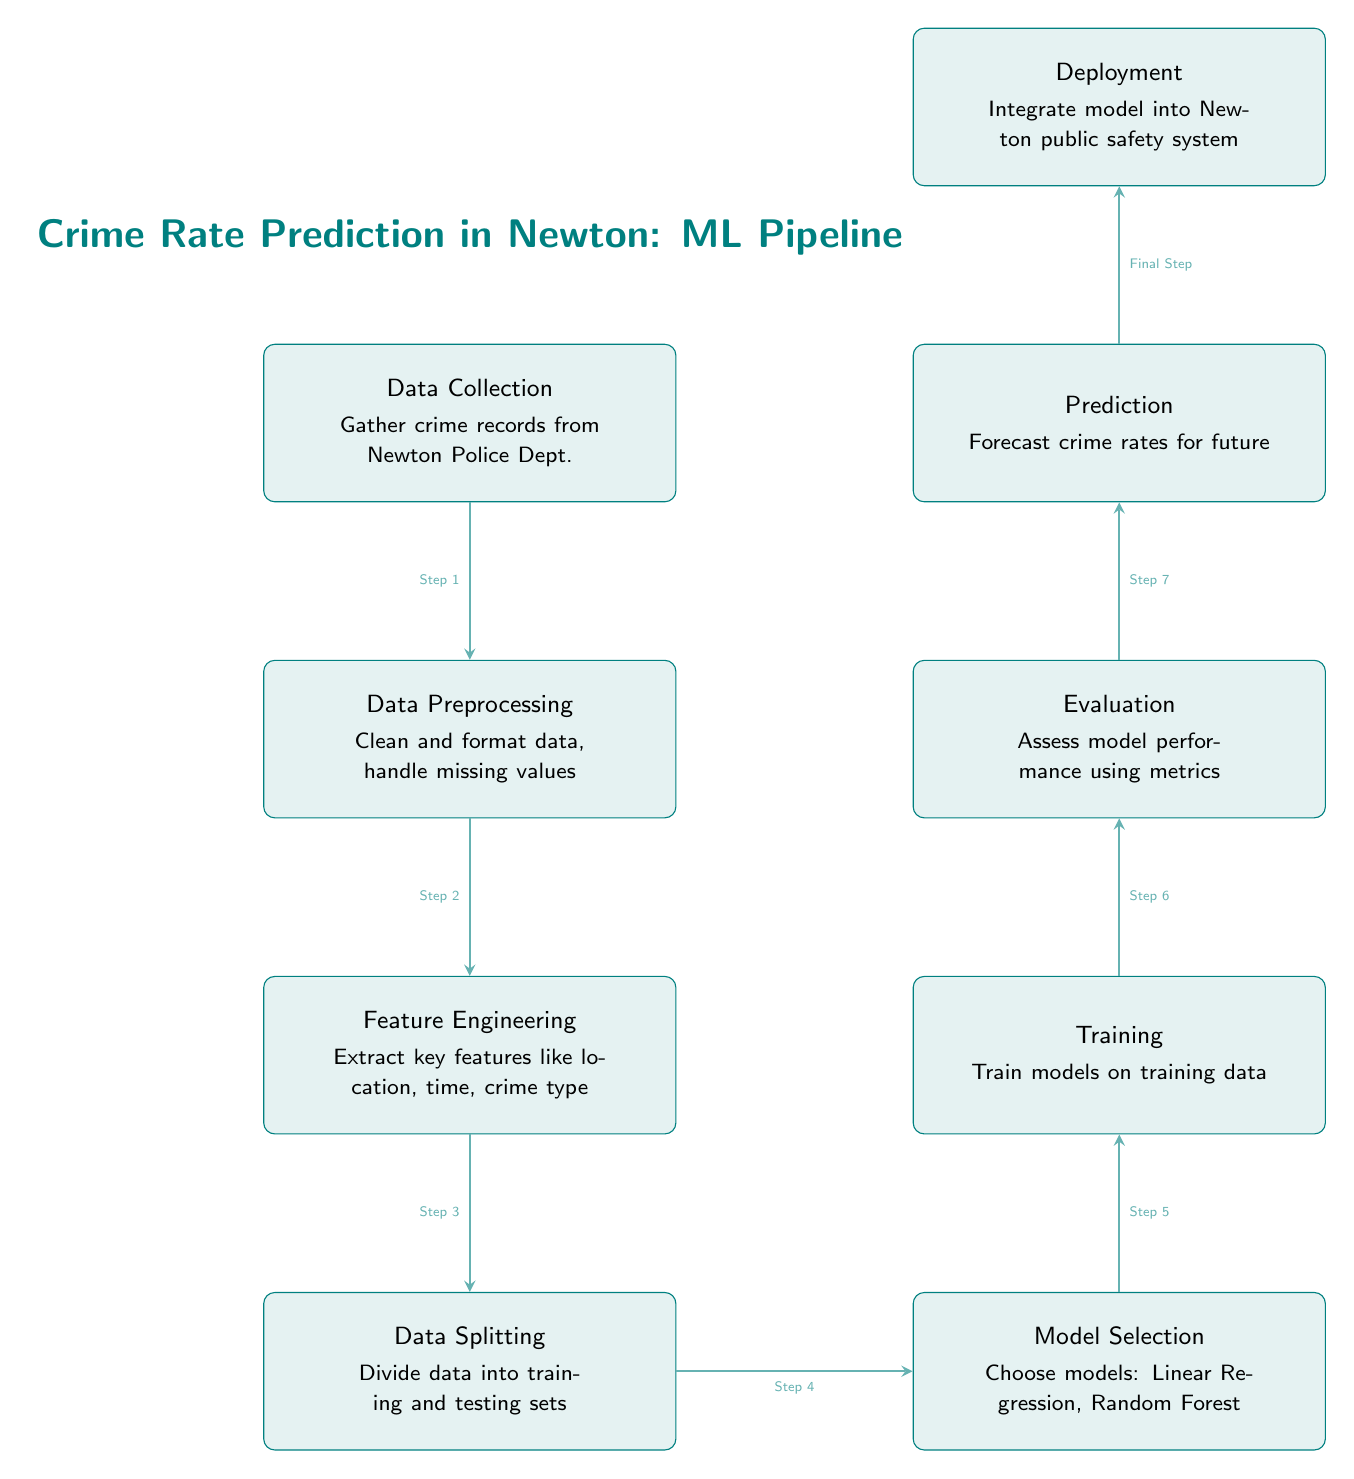What is the first step in the ML pipeline? The first step in the ML pipeline is "Data Collection," which involves gathering crime records from the Newton Police Department.
Answer: Data Collection What type of models are selected in the Model Selection step? The models selected in the Model Selection step are Linear Regression and Random Forest, as indicated in the diagram.
Answer: Linear Regression, Random Forest How many main steps are there in the ML pipeline? There are seven main steps in the ML pipeline, starting from Data Collection to Deployment as outlined in the sequence of nodes.
Answer: Seven Which process comes immediately after Data Preprocessing? The process that comes immediately after Data Preprocessing is Feature Engineering, as shown in the directional flow from one box to the next.
Answer: Feature Engineering What is the final output of the ML pipeline? The final output of the ML pipeline is "Deployment," where the model is integrated into the Newton public safety system.
Answer: Deployment What do we do during the Evaluation step? During the Evaluation step, we assess model performance using various metrics, which is an important process in validating the model's effectiveness.
Answer: Assess model performance using metrics Where does the training of the models occur in the diagram? The training of the models occurs in the Training step, which is placed in the sequence after Model Selection and before Evaluation.
Answer: Training What key features are extracted during Feature Engineering? Key features extracted during Feature Engineering include location, time, and crime type, as specified in the process box for that step.
Answer: Location, time, crime type What happens to the data before it is split into training and testing sets? Before the data is split into training and testing sets, it undergoes Data Preprocessing, which includes cleaning and formatting the data and handling missing values.
Answer: Data Preprocessing 